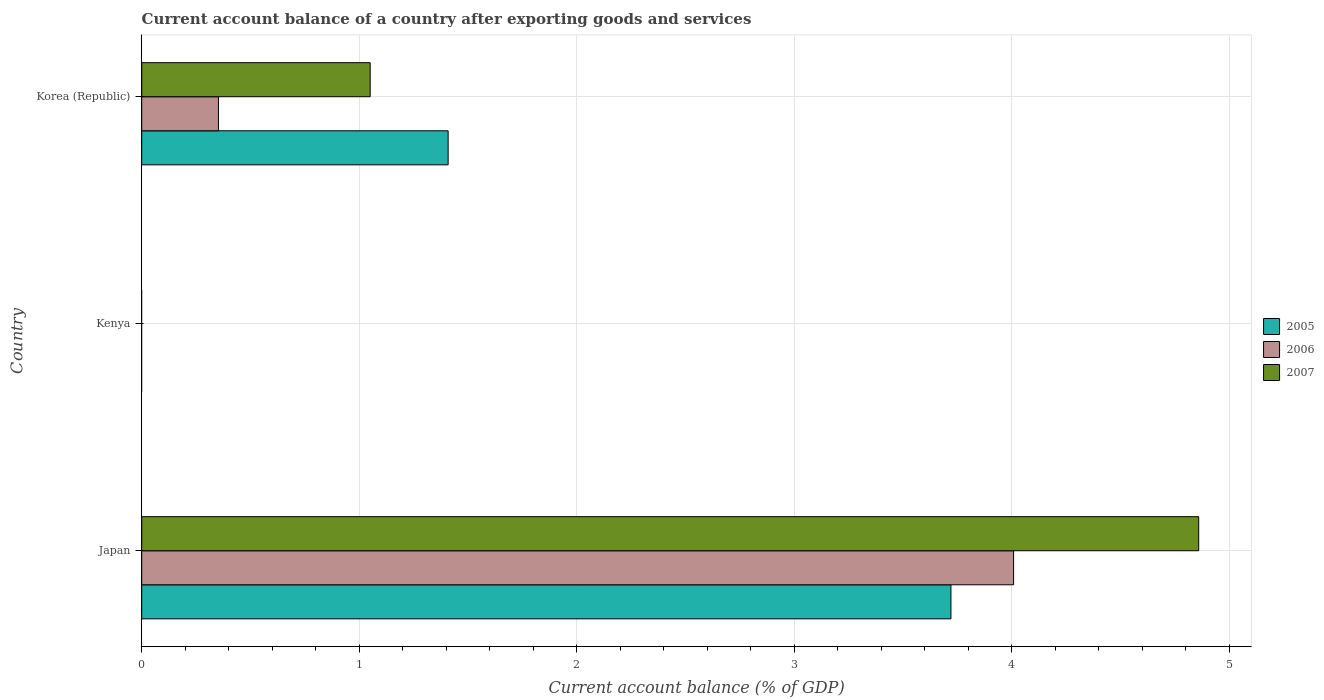How many different coloured bars are there?
Ensure brevity in your answer.  3. Are the number of bars per tick equal to the number of legend labels?
Make the answer very short. No. Are the number of bars on each tick of the Y-axis equal?
Provide a succinct answer. No. What is the account balance in 2006 in Japan?
Make the answer very short. 4.01. Across all countries, what is the maximum account balance in 2007?
Give a very brief answer. 4.86. What is the total account balance in 2005 in the graph?
Make the answer very short. 5.13. What is the difference between the account balance in 2006 in Japan and that in Korea (Republic)?
Ensure brevity in your answer.  3.66. What is the difference between the account balance in 2005 in Kenya and the account balance in 2007 in Korea (Republic)?
Offer a very short reply. -1.05. What is the average account balance in 2007 per country?
Make the answer very short. 1.97. What is the difference between the account balance in 2005 and account balance in 2007 in Korea (Republic)?
Your answer should be compact. 0.36. What is the ratio of the account balance in 2006 in Japan to that in Korea (Republic)?
Your answer should be compact. 11.37. What is the difference between the highest and the lowest account balance in 2005?
Offer a very short reply. 3.72. In how many countries, is the account balance in 2005 greater than the average account balance in 2005 taken over all countries?
Make the answer very short. 1. Is it the case that in every country, the sum of the account balance in 2006 and account balance in 2007 is greater than the account balance in 2005?
Provide a short and direct response. No. Are all the bars in the graph horizontal?
Ensure brevity in your answer.  Yes. How many countries are there in the graph?
Your answer should be very brief. 3. Are the values on the major ticks of X-axis written in scientific E-notation?
Provide a short and direct response. No. Does the graph contain any zero values?
Provide a short and direct response. Yes. Does the graph contain grids?
Your answer should be very brief. Yes. How many legend labels are there?
Your response must be concise. 3. What is the title of the graph?
Your answer should be compact. Current account balance of a country after exporting goods and services. Does "1961" appear as one of the legend labels in the graph?
Provide a succinct answer. No. What is the label or title of the X-axis?
Provide a succinct answer. Current account balance (% of GDP). What is the Current account balance (% of GDP) of 2005 in Japan?
Offer a very short reply. 3.72. What is the Current account balance (% of GDP) of 2006 in Japan?
Ensure brevity in your answer.  4.01. What is the Current account balance (% of GDP) in 2007 in Japan?
Offer a terse response. 4.86. What is the Current account balance (% of GDP) in 2006 in Kenya?
Keep it short and to the point. 0. What is the Current account balance (% of GDP) of 2005 in Korea (Republic)?
Your response must be concise. 1.41. What is the Current account balance (% of GDP) in 2006 in Korea (Republic)?
Keep it short and to the point. 0.35. What is the Current account balance (% of GDP) of 2007 in Korea (Republic)?
Offer a very short reply. 1.05. Across all countries, what is the maximum Current account balance (% of GDP) of 2005?
Give a very brief answer. 3.72. Across all countries, what is the maximum Current account balance (% of GDP) in 2006?
Make the answer very short. 4.01. Across all countries, what is the maximum Current account balance (% of GDP) in 2007?
Offer a very short reply. 4.86. Across all countries, what is the minimum Current account balance (% of GDP) of 2005?
Your response must be concise. 0. Across all countries, what is the minimum Current account balance (% of GDP) in 2006?
Offer a terse response. 0. Across all countries, what is the minimum Current account balance (% of GDP) of 2007?
Keep it short and to the point. 0. What is the total Current account balance (% of GDP) of 2005 in the graph?
Offer a very short reply. 5.13. What is the total Current account balance (% of GDP) of 2006 in the graph?
Give a very brief answer. 4.36. What is the total Current account balance (% of GDP) in 2007 in the graph?
Give a very brief answer. 5.91. What is the difference between the Current account balance (% of GDP) in 2005 in Japan and that in Korea (Republic)?
Make the answer very short. 2.31. What is the difference between the Current account balance (% of GDP) in 2006 in Japan and that in Korea (Republic)?
Make the answer very short. 3.66. What is the difference between the Current account balance (% of GDP) in 2007 in Japan and that in Korea (Republic)?
Your answer should be very brief. 3.81. What is the difference between the Current account balance (% of GDP) in 2005 in Japan and the Current account balance (% of GDP) in 2006 in Korea (Republic)?
Make the answer very short. 3.37. What is the difference between the Current account balance (% of GDP) in 2005 in Japan and the Current account balance (% of GDP) in 2007 in Korea (Republic)?
Your answer should be compact. 2.67. What is the difference between the Current account balance (% of GDP) of 2006 in Japan and the Current account balance (% of GDP) of 2007 in Korea (Republic)?
Keep it short and to the point. 2.96. What is the average Current account balance (% of GDP) in 2005 per country?
Your answer should be very brief. 1.71. What is the average Current account balance (% of GDP) of 2006 per country?
Offer a very short reply. 1.45. What is the average Current account balance (% of GDP) in 2007 per country?
Your response must be concise. 1.97. What is the difference between the Current account balance (% of GDP) in 2005 and Current account balance (% of GDP) in 2006 in Japan?
Make the answer very short. -0.29. What is the difference between the Current account balance (% of GDP) of 2005 and Current account balance (% of GDP) of 2007 in Japan?
Your response must be concise. -1.14. What is the difference between the Current account balance (% of GDP) of 2006 and Current account balance (% of GDP) of 2007 in Japan?
Provide a short and direct response. -0.85. What is the difference between the Current account balance (% of GDP) of 2005 and Current account balance (% of GDP) of 2006 in Korea (Republic)?
Keep it short and to the point. 1.06. What is the difference between the Current account balance (% of GDP) in 2005 and Current account balance (% of GDP) in 2007 in Korea (Republic)?
Give a very brief answer. 0.36. What is the difference between the Current account balance (% of GDP) of 2006 and Current account balance (% of GDP) of 2007 in Korea (Republic)?
Your response must be concise. -0.7. What is the ratio of the Current account balance (% of GDP) in 2005 in Japan to that in Korea (Republic)?
Provide a succinct answer. 2.64. What is the ratio of the Current account balance (% of GDP) of 2006 in Japan to that in Korea (Republic)?
Ensure brevity in your answer.  11.37. What is the ratio of the Current account balance (% of GDP) in 2007 in Japan to that in Korea (Republic)?
Ensure brevity in your answer.  4.63. What is the difference between the highest and the lowest Current account balance (% of GDP) in 2005?
Keep it short and to the point. 3.72. What is the difference between the highest and the lowest Current account balance (% of GDP) in 2006?
Offer a very short reply. 4.01. What is the difference between the highest and the lowest Current account balance (% of GDP) in 2007?
Offer a terse response. 4.86. 